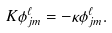Convert formula to latex. <formula><loc_0><loc_0><loc_500><loc_500>K \phi ^ { \ell } _ { j m } = - \kappa \phi ^ { \ell } _ { j m } .</formula> 